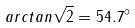<formula> <loc_0><loc_0><loc_500><loc_500>a r c t a n \sqrt { 2 } = 5 4 . 7 ^ { \circ }</formula> 